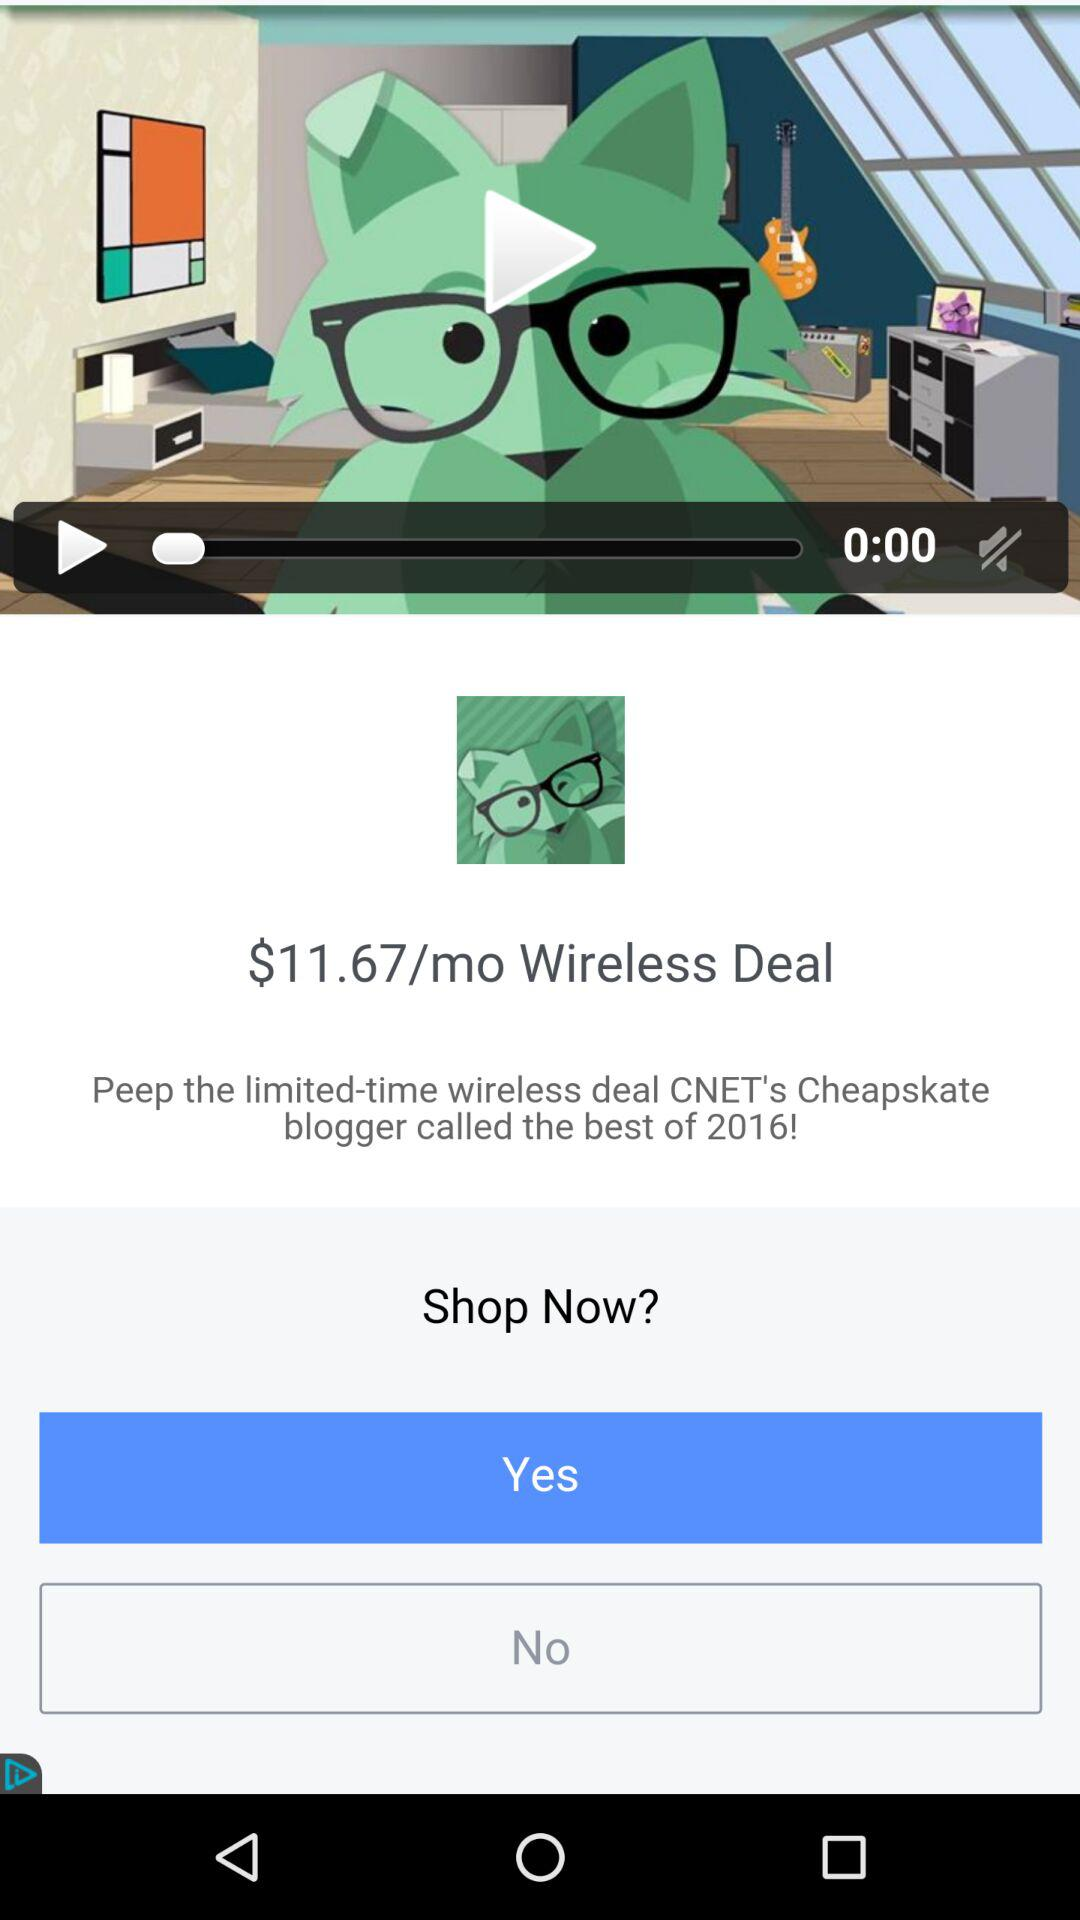How much is the wireless deal?
Answer the question using a single word or phrase. $11.67/mo 